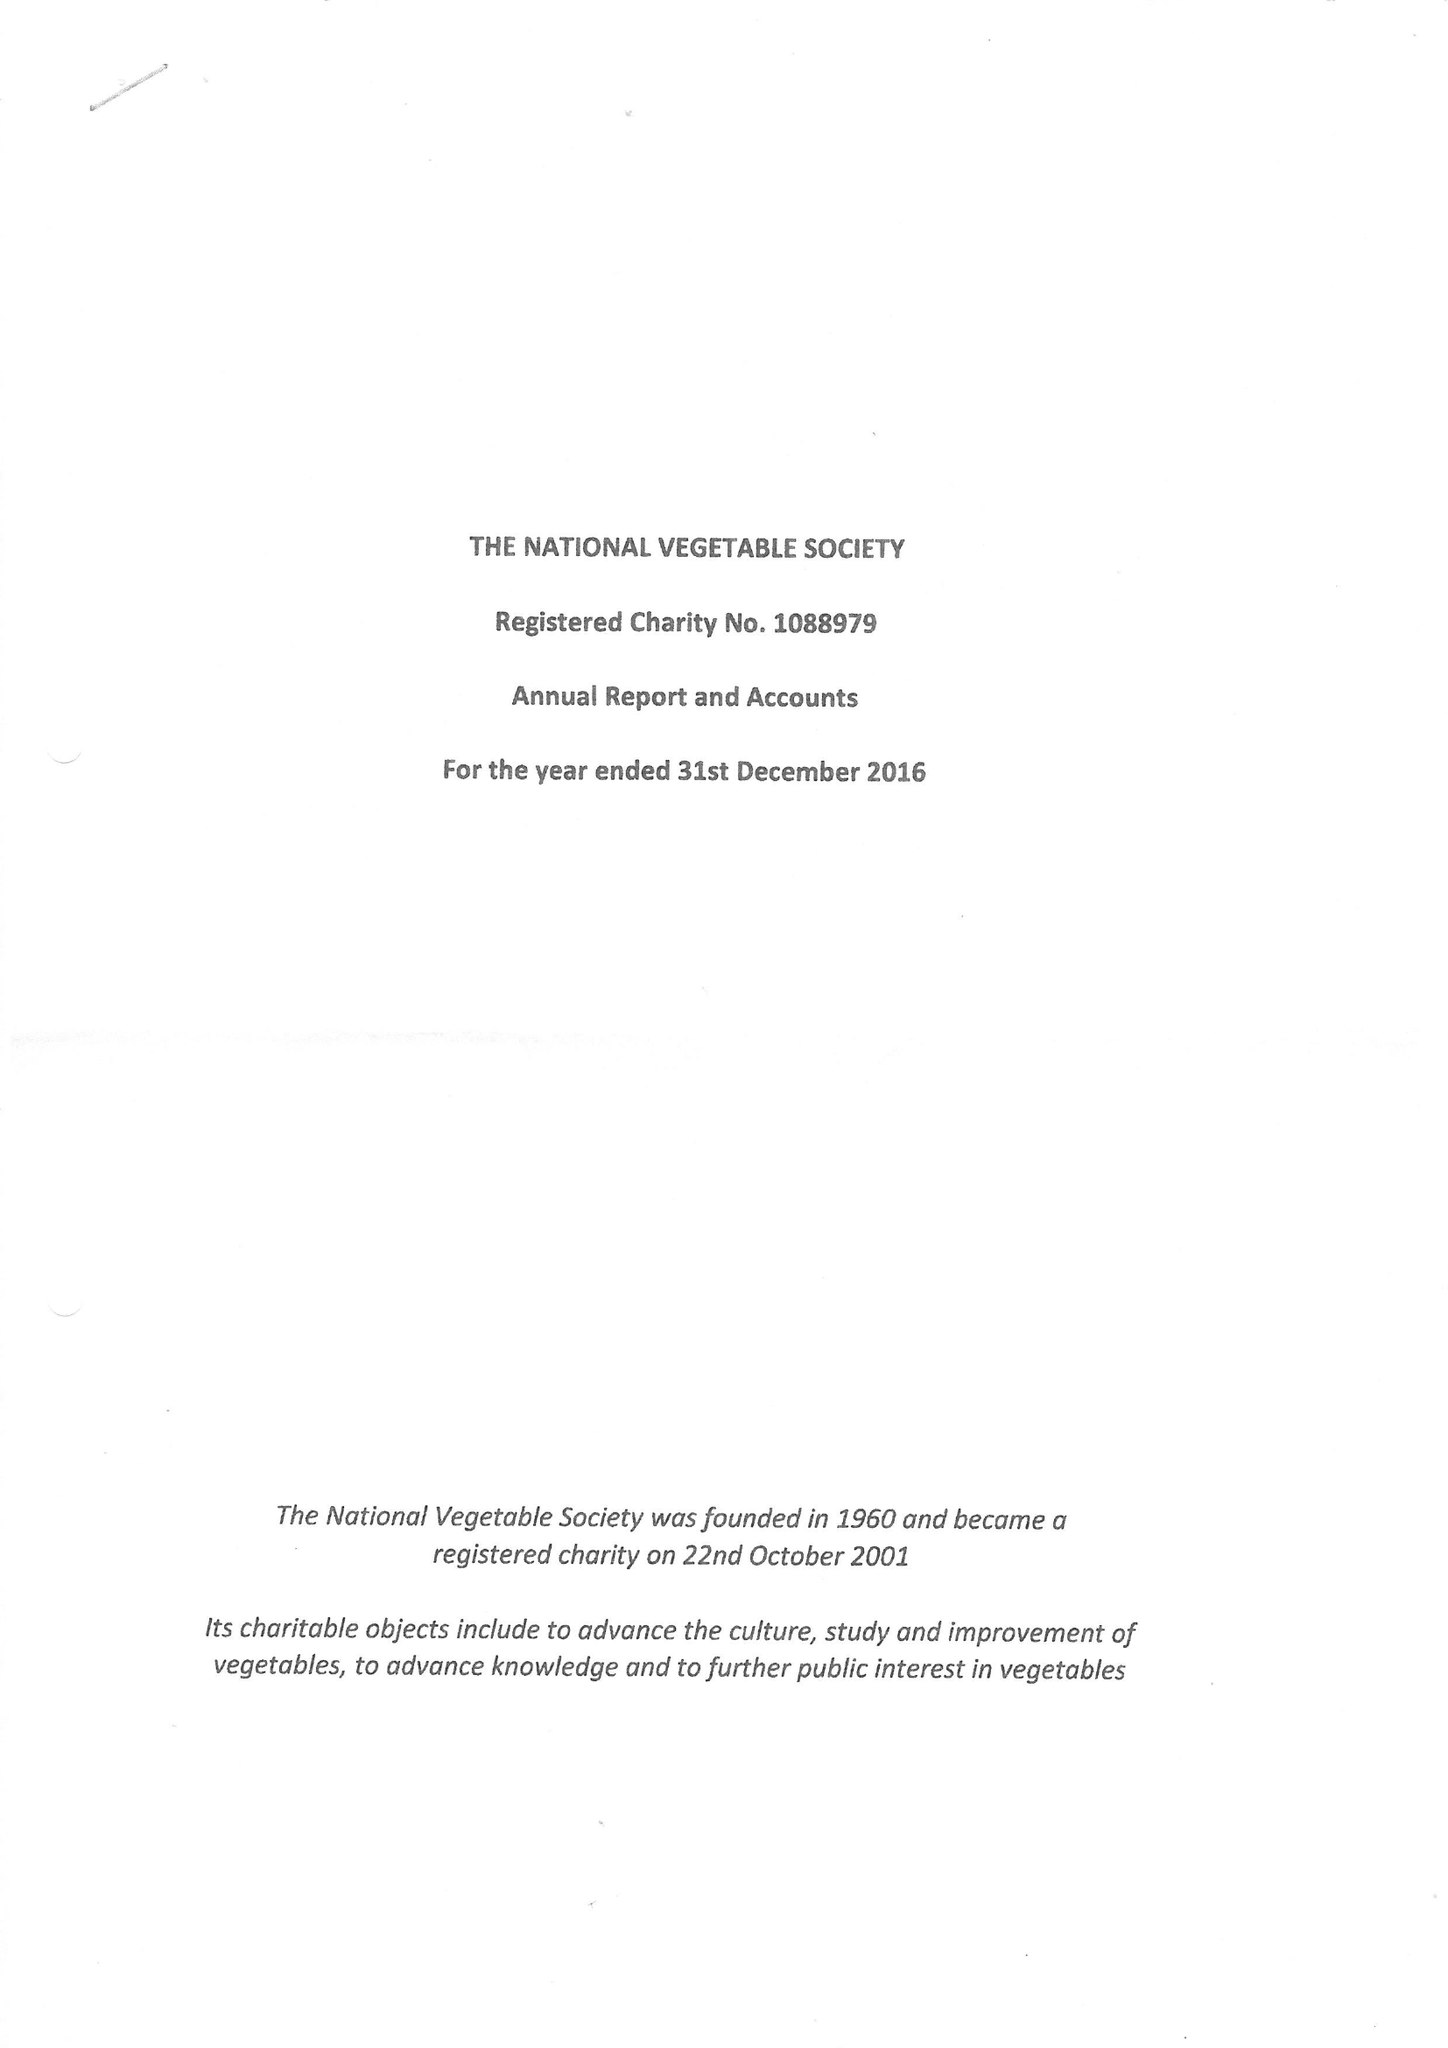What is the value for the spending_annually_in_british_pounds?
Answer the question using a single word or phrase. 115819.00 